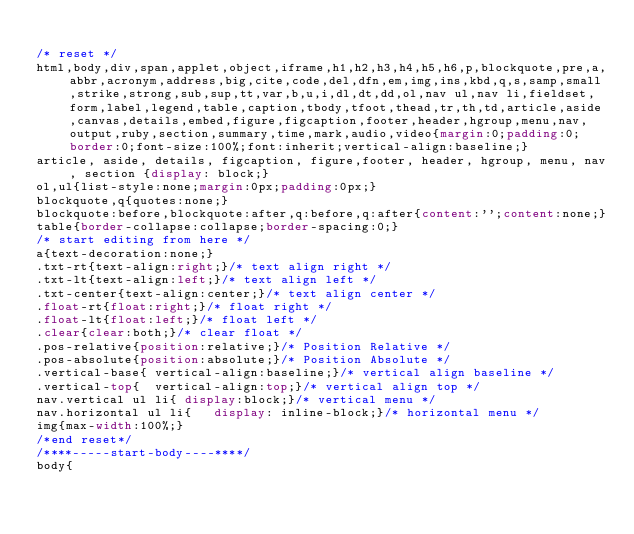<code> <loc_0><loc_0><loc_500><loc_500><_CSS_>
/* reset */
html,body,div,span,applet,object,iframe,h1,h2,h3,h4,h5,h6,p,blockquote,pre,a,abbr,acronym,address,big,cite,code,del,dfn,em,img,ins,kbd,q,s,samp,small,strike,strong,sub,sup,tt,var,b,u,i,dl,dt,dd,ol,nav ul,nav li,fieldset,form,label,legend,table,caption,tbody,tfoot,thead,tr,th,td,article,aside,canvas,details,embed,figure,figcaption,footer,header,hgroup,menu,nav,output,ruby,section,summary,time,mark,audio,video{margin:0;padding:0;border:0;font-size:100%;font:inherit;vertical-align:baseline;}
article, aside, details, figcaption, figure,footer, header, hgroup, menu, nav, section {display: block;}
ol,ul{list-style:none;margin:0px;padding:0px;}
blockquote,q{quotes:none;}
blockquote:before,blockquote:after,q:before,q:after{content:'';content:none;}
table{border-collapse:collapse;border-spacing:0;}
/* start editing from here */
a{text-decoration:none;}
.txt-rt{text-align:right;}/* text align right */
.txt-lt{text-align:left;}/* text align left */
.txt-center{text-align:center;}/* text align center */
.float-rt{float:right;}/* float right */
.float-lt{float:left;}/* float left */
.clear{clear:both;}/* clear float */
.pos-relative{position:relative;}/* Position Relative */
.pos-absolute{position:absolute;}/* Position Absolute */
.vertical-base{	vertical-align:baseline;}/* vertical align baseline */
.vertical-top{	vertical-align:top;}/* vertical align top */
nav.vertical ul li{	display:block;}/* vertical menu */
nav.horizontal ul li{	display: inline-block;}/* horizontal menu */
img{max-width:100%;}
/*end reset*/
/****-----start-body----****/
body{</code> 